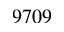<formula> <loc_0><loc_0><loc_500><loc_500>9 7 0 9</formula> 